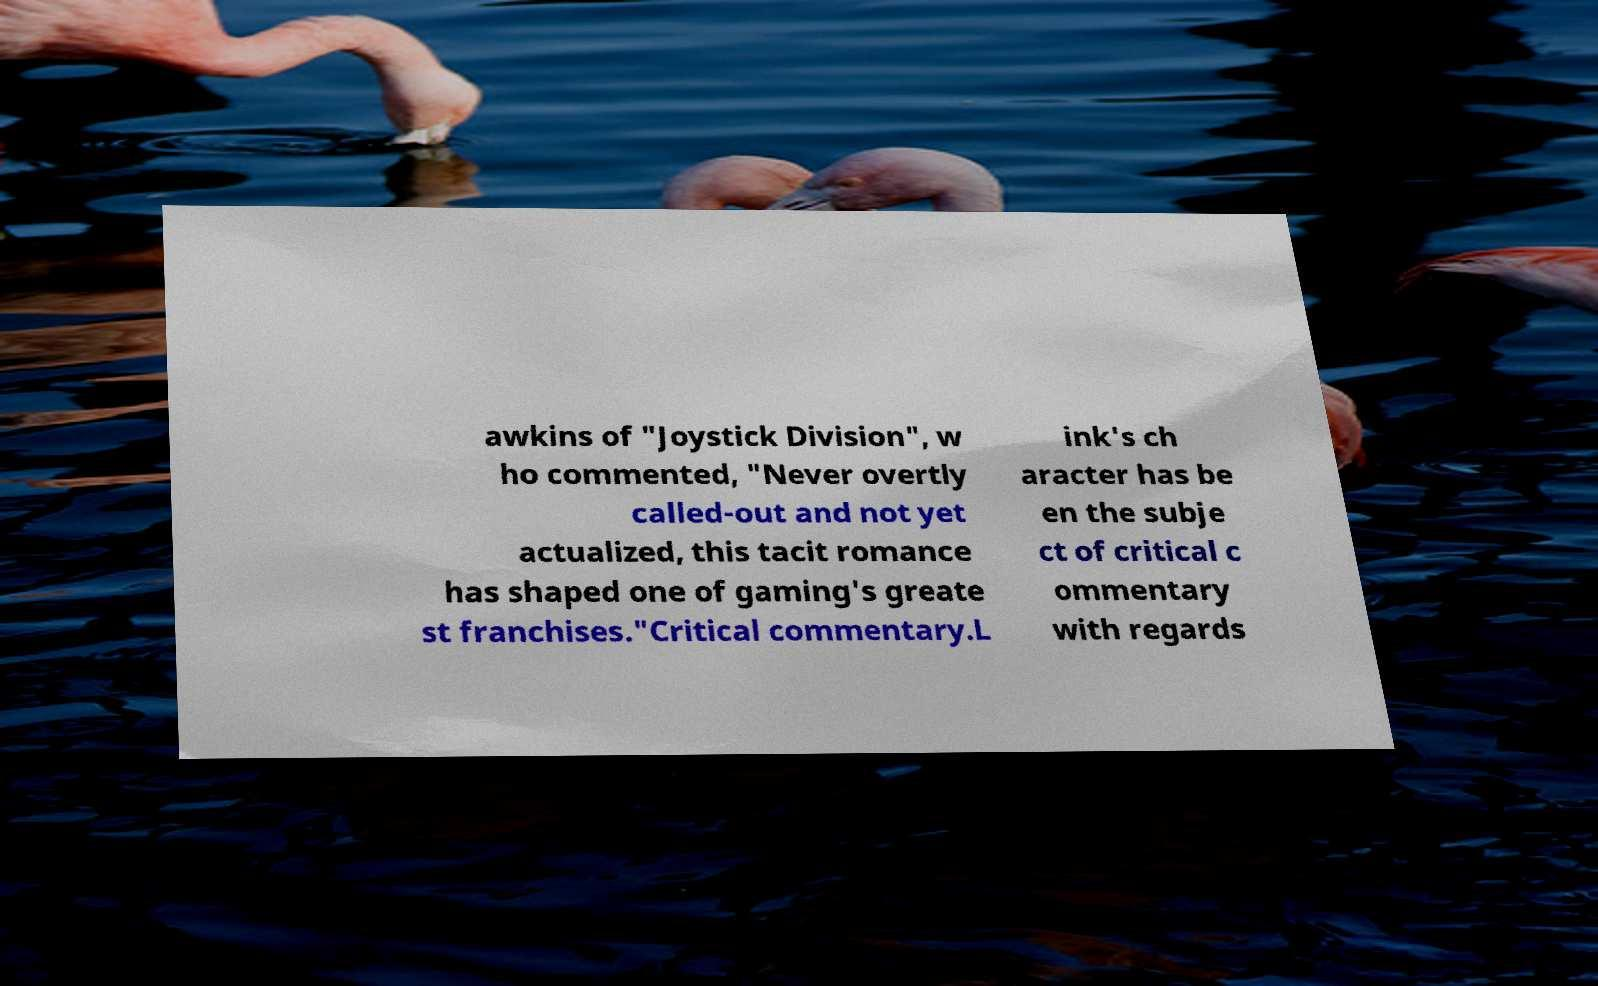What messages or text are displayed in this image? I need them in a readable, typed format. awkins of "Joystick Division", w ho commented, "Never overtly called-out and not yet actualized, this tacit romance has shaped one of gaming's greate st franchises."Critical commentary.L ink's ch aracter has be en the subje ct of critical c ommentary with regards 